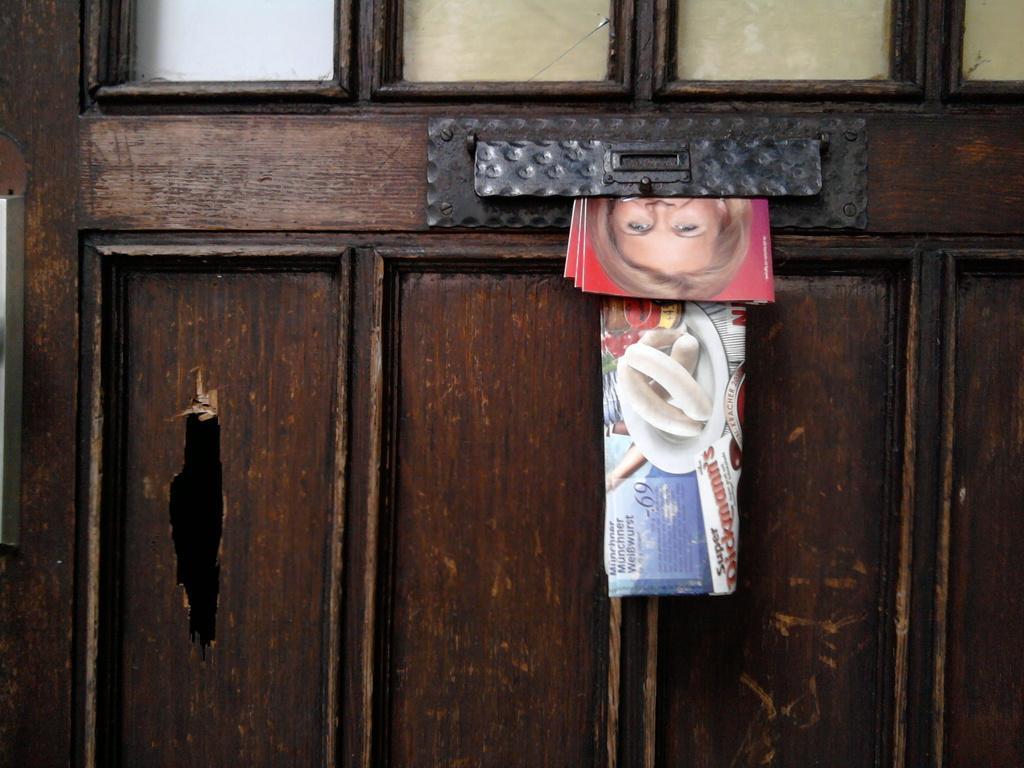How would you summarize this image in a sentence or two? In the given image i can see a wooden object including newspaper and photo books. 